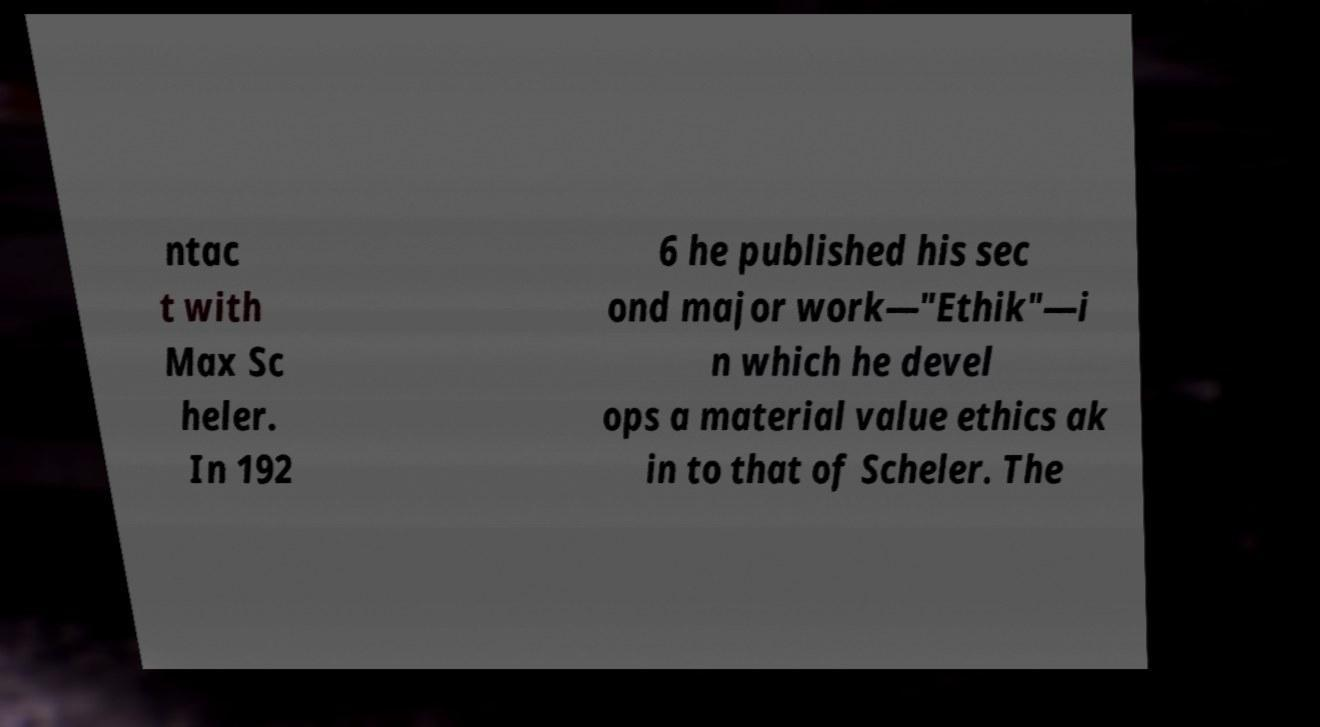Could you extract and type out the text from this image? ntac t with Max Sc heler. In 192 6 he published his sec ond major work—"Ethik"—i n which he devel ops a material value ethics ak in to that of Scheler. The 